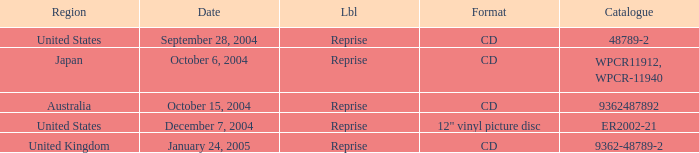Name the label for january 24, 2005 Reprise. 